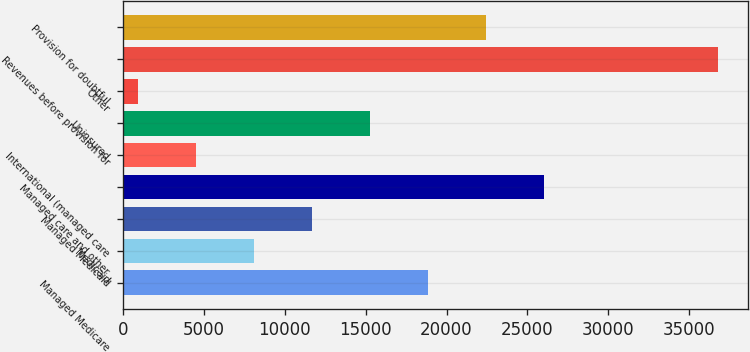Convert chart to OTSL. <chart><loc_0><loc_0><loc_500><loc_500><bar_chart><fcel>Managed Medicare<fcel>Medicaid<fcel>Managed Medicaid<fcel>Managed care and other<fcel>International (managed care<fcel>Uninsured<fcel>Other<fcel>Revenues before provision for<fcel>Provision for doubtful<nl><fcel>18857<fcel>8101.4<fcel>11686.6<fcel>26027.4<fcel>4516.2<fcel>15271.8<fcel>931<fcel>36783<fcel>22442.2<nl></chart> 